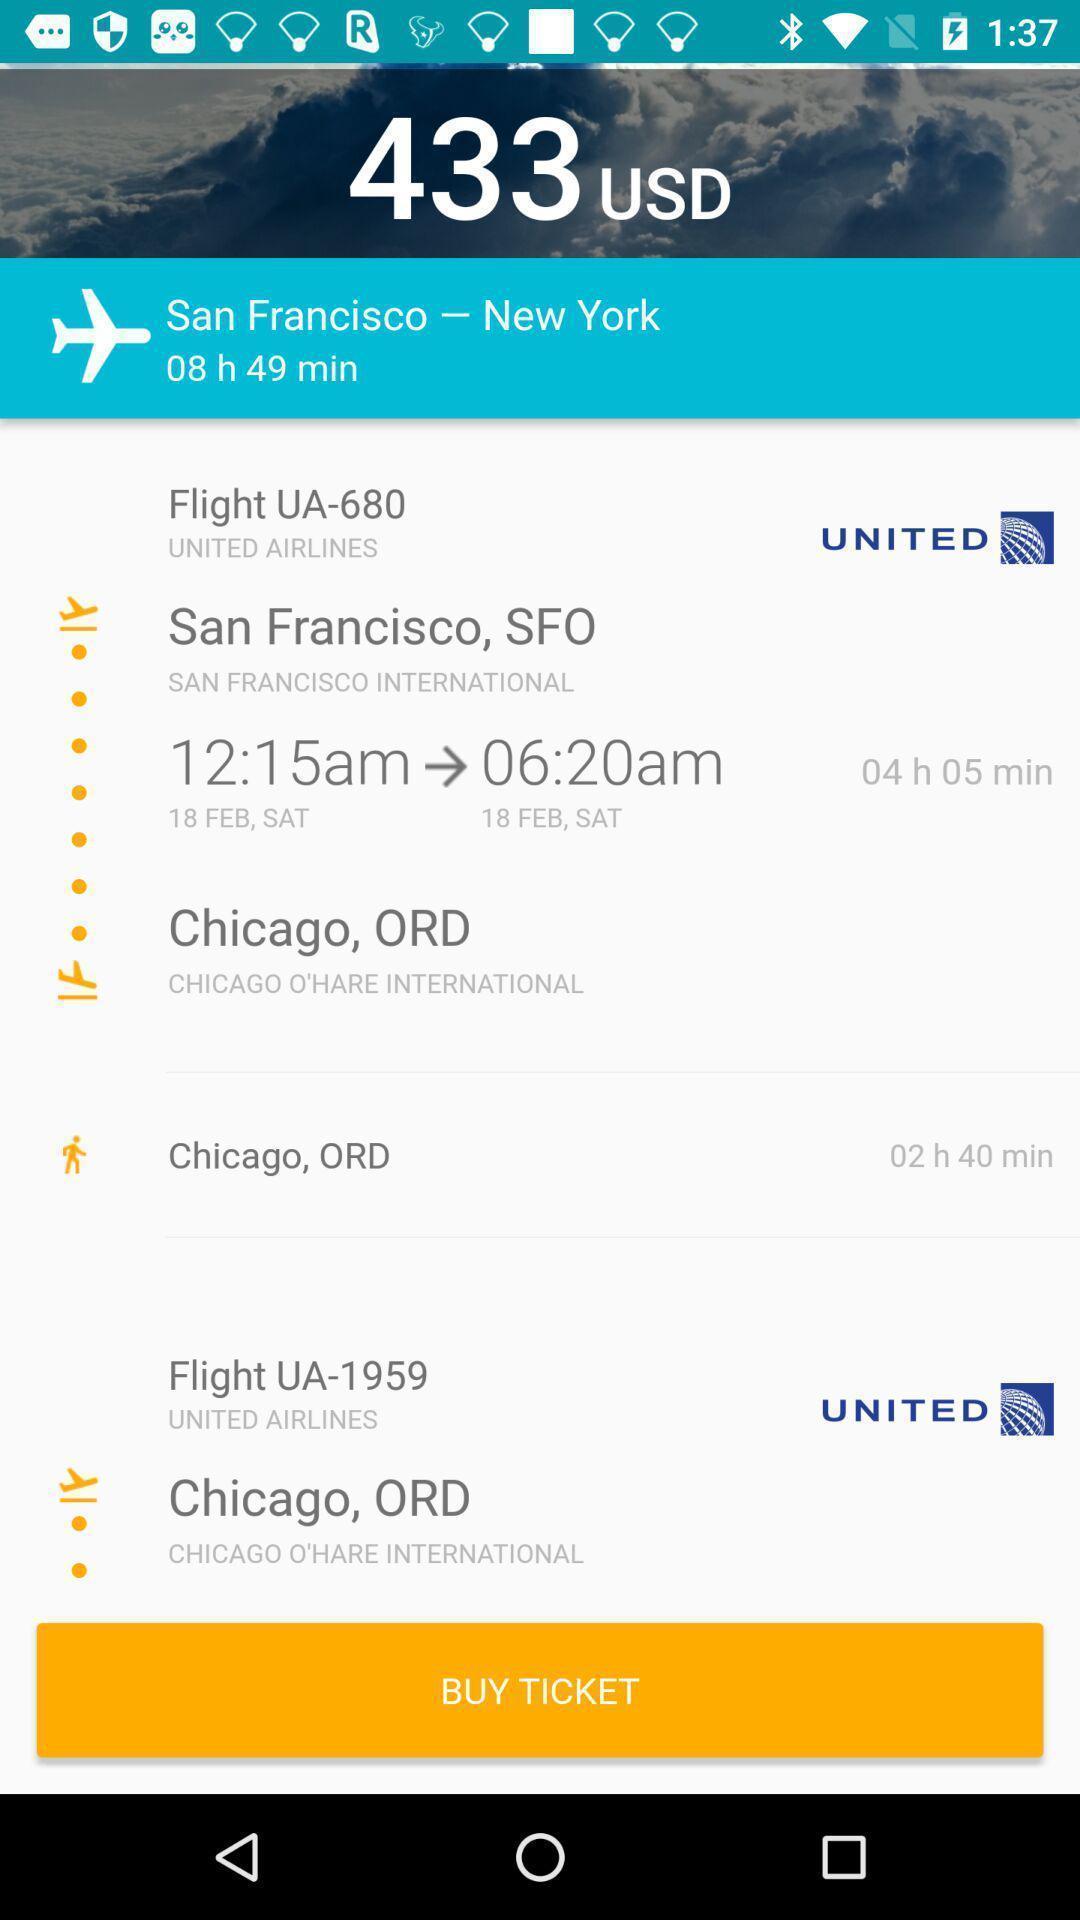Summarize the main components in this picture. Various flight details displayed of an travel app. 